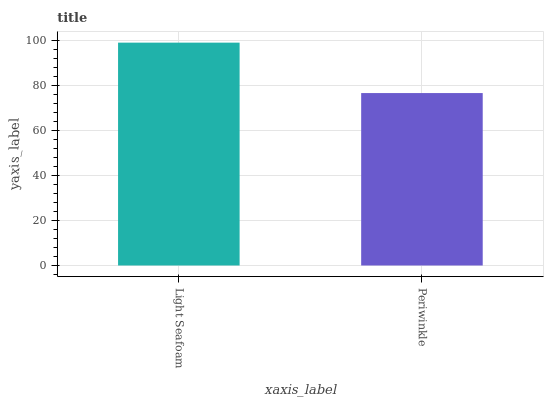Is Periwinkle the minimum?
Answer yes or no. Yes. Is Light Seafoam the maximum?
Answer yes or no. Yes. Is Periwinkle the maximum?
Answer yes or no. No. Is Light Seafoam greater than Periwinkle?
Answer yes or no. Yes. Is Periwinkle less than Light Seafoam?
Answer yes or no. Yes. Is Periwinkle greater than Light Seafoam?
Answer yes or no. No. Is Light Seafoam less than Periwinkle?
Answer yes or no. No. Is Light Seafoam the high median?
Answer yes or no. Yes. Is Periwinkle the low median?
Answer yes or no. Yes. Is Periwinkle the high median?
Answer yes or no. No. Is Light Seafoam the low median?
Answer yes or no. No. 